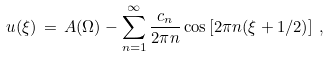<formula> <loc_0><loc_0><loc_500><loc_500>u ( \xi ) \, = \, A ( \Omega ) - \sum _ { n = 1 } ^ { \infty } \frac { c _ { n } } { 2 \pi n } \cos \left [ 2 \pi n ( \xi + 1 / 2 ) \right ] \, ,</formula> 